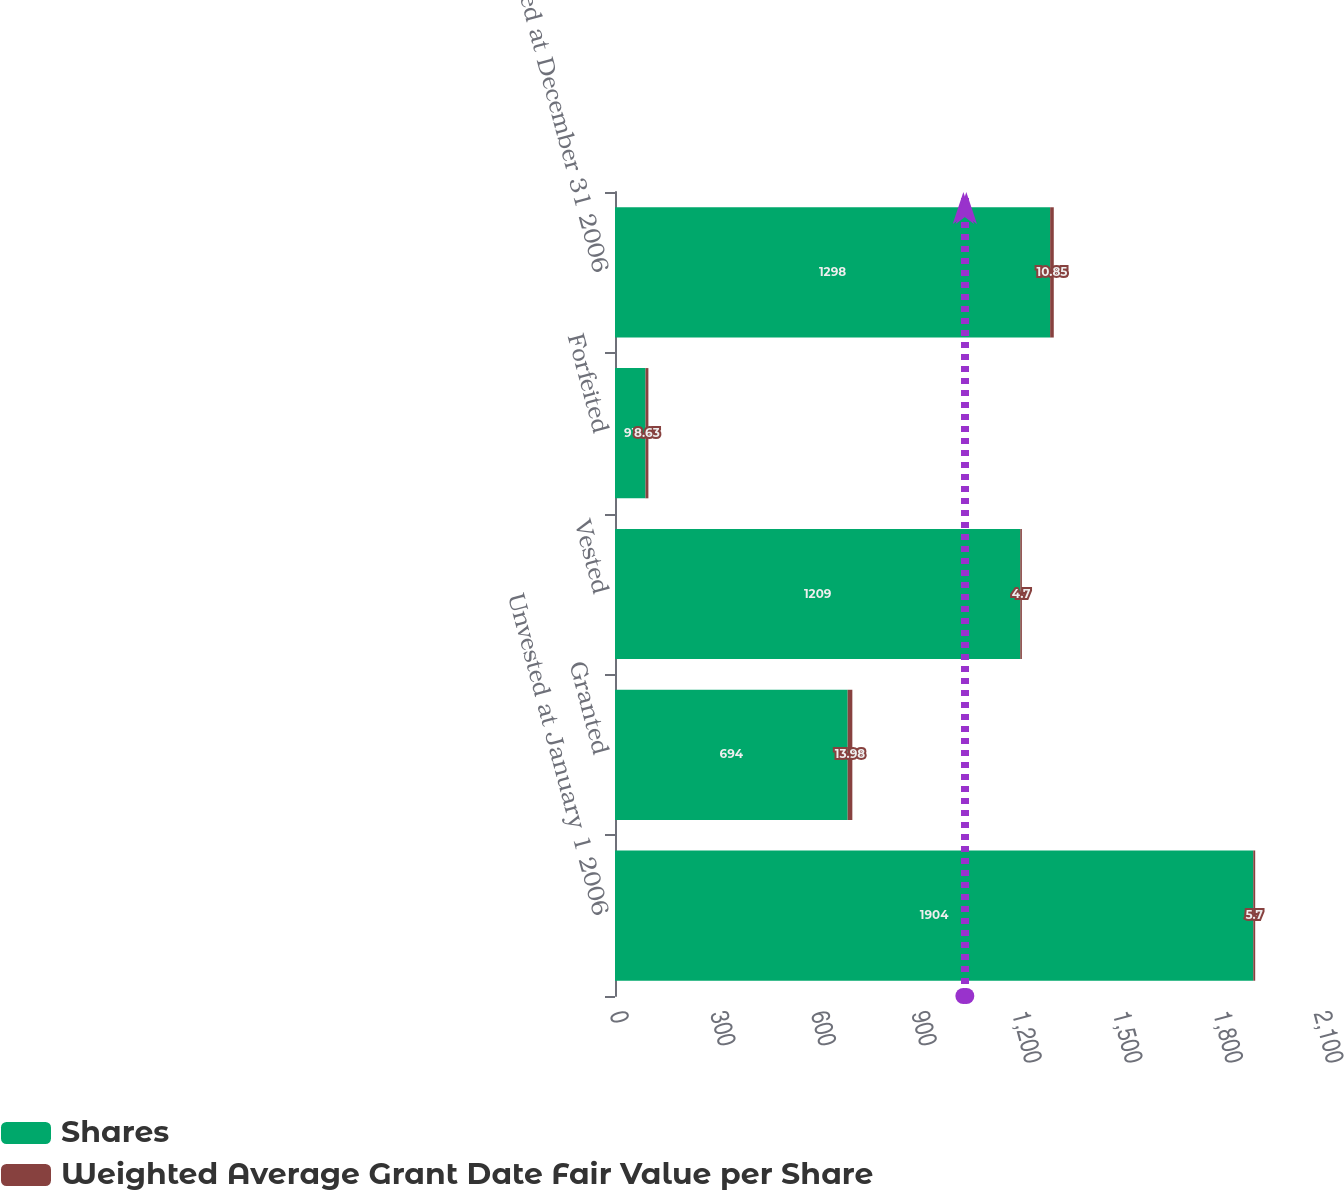Convert chart to OTSL. <chart><loc_0><loc_0><loc_500><loc_500><stacked_bar_chart><ecel><fcel>Unvested at January 1 2006<fcel>Granted<fcel>Vested<fcel>Forfeited<fcel>Unvested at December 31 2006<nl><fcel>Shares<fcel>1904<fcel>694<fcel>1209<fcel>91<fcel>1298<nl><fcel>Weighted Average Grant Date Fair Value per Share<fcel>5.7<fcel>13.98<fcel>4.7<fcel>8.63<fcel>10.85<nl></chart> 